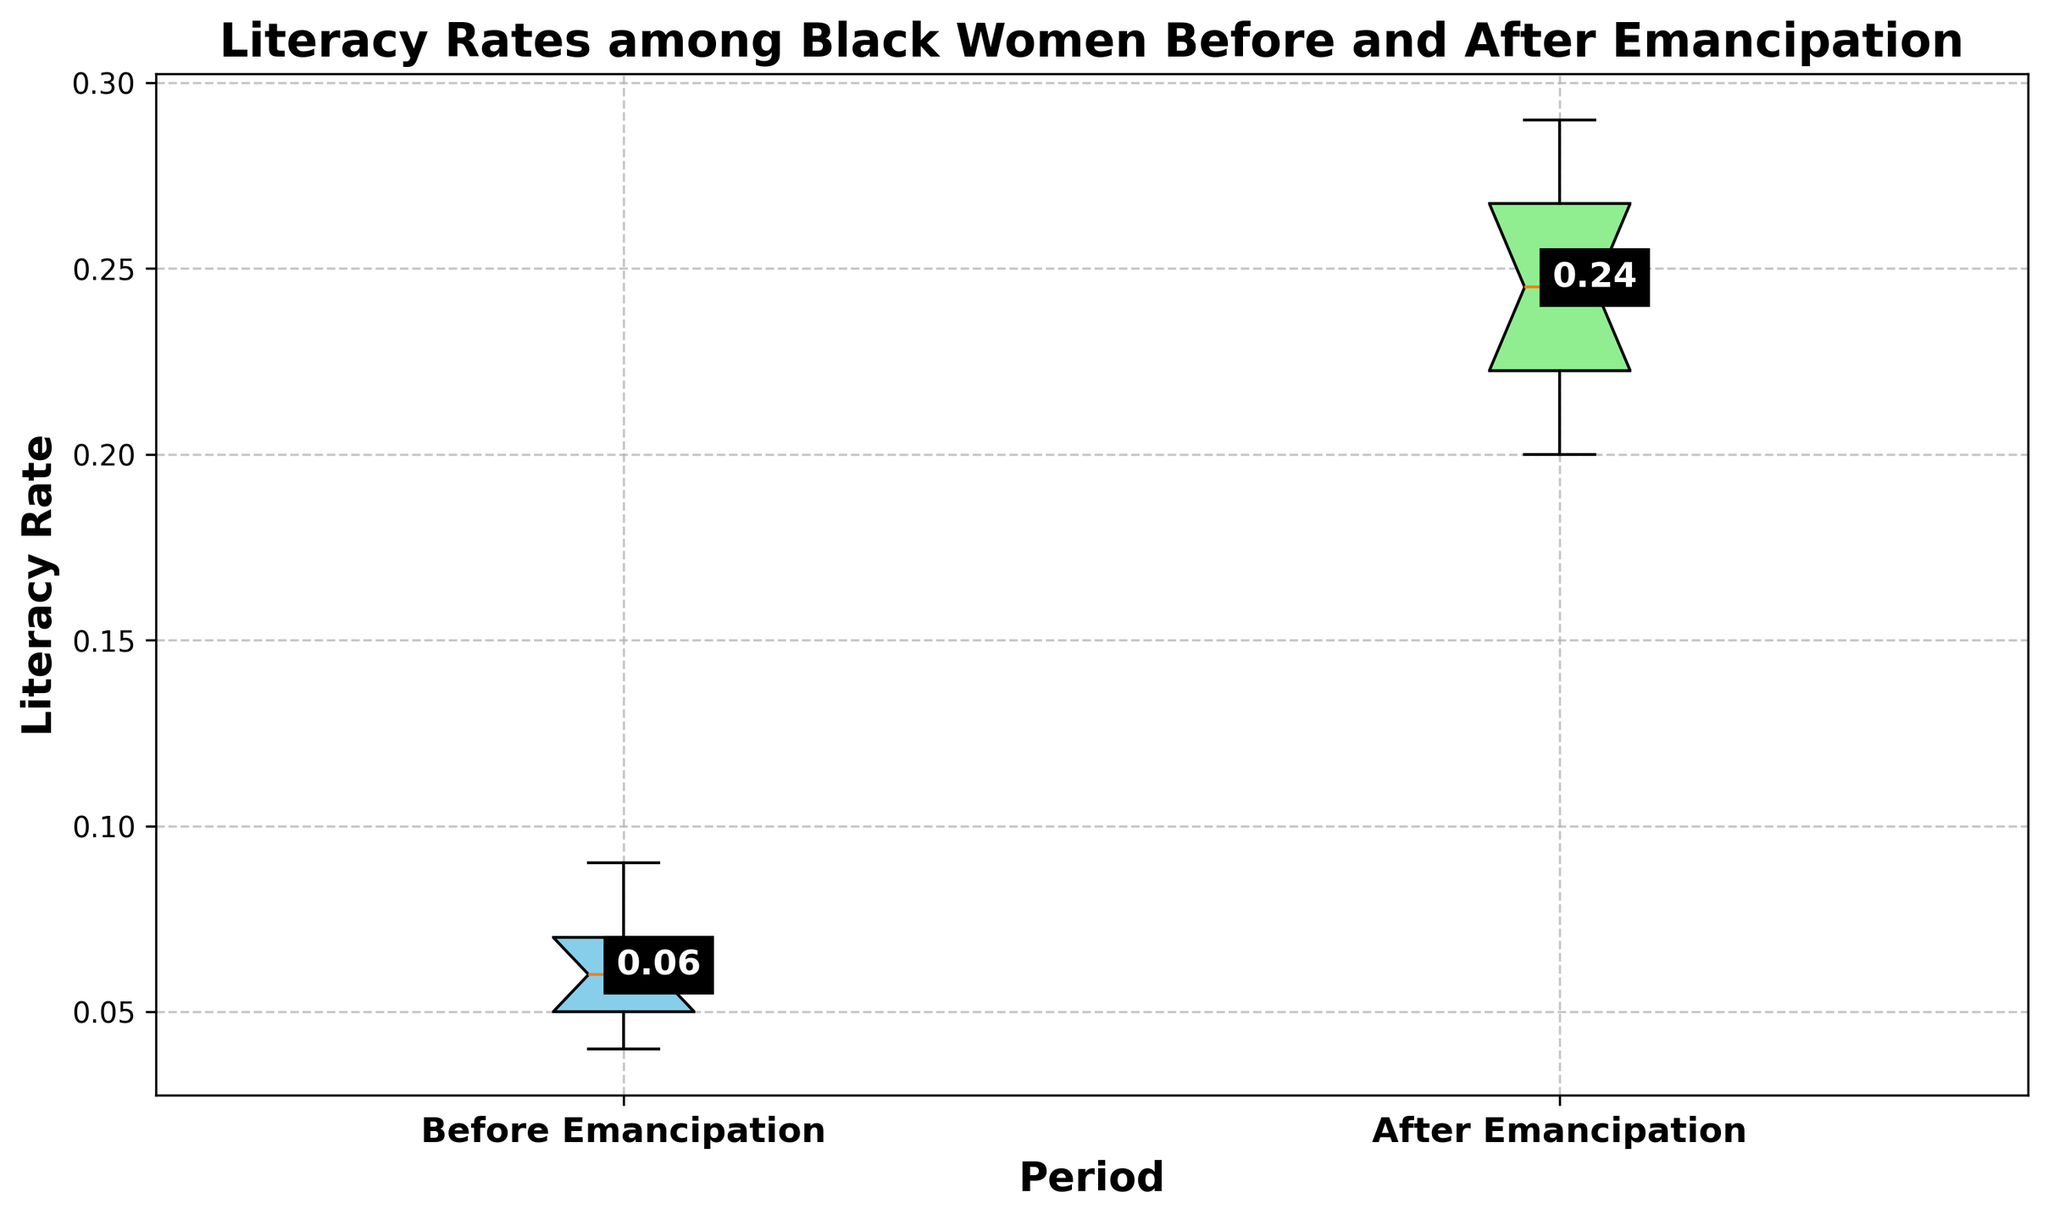What's the median literacy rate before the Emancipation Proclamation? To find the median literacy rate before Emancipation, look at the middle value of the ordered literacy rates in that period, identified by the horizontal line inside the box for "Before Emancipation".
Answer: 0.06 What's the median literacy rate after the Emancipation Proclamation? The median literacy rate after Emancipation, shown by the horizontal line in the box for "After Emancipation", represents the middle value of the ordered literacy rates in that period.
Answer: 0.24 Which period shows a higher median literacy rate? Compare the median lines between the two periods to determine which one is higher. The box for "After Emancipation" has a higher median line than "Before Emancipation".
Answer: After Emancipation What's the difference between the highest literacy rates before and after the Emancipation Proclamation? Identify the top whiskers of the box plots which indicate the maximum literacy rates. For "Before Emancipation" it's 0.09, and for "After Emancipation" it's 0.29. Subtract the former from the latter.
Answer: 0.20 How do the interquartile ranges (IQR) compare between the two periods? The IQR is the range between the first quartile (bottom of the box) and third quartile (top of the box). Compare the height of the boxes for each period. The IQR for "Before Emancipation" is very small, while "After Emancipation" has a larger IQR, indicating higher variability.
Answer: The IQR is larger after Emancipation Is there any overlap in the literacy rates between the two periods? The range of values is indicated by the whiskers of the box plots. The maximum value before Emancipation (0.09) is less than the minimum value after Emancipation (0.20), showing no overlap.
Answer: No What visual attribute indicates the higher literacy rates in the "After Emancipation" group? The box plot for "After Emancipation" is higher on the y-axis, with the median and quartiles all shifted upwards compared to "Before Emancipation".
Answer: Higher placement on the y-axis How does the range of literacy rates compare between the two periods? Examine the whiskers of each box plot. The range for "Before Emancipation" is from 0.04 to 0.09, while for "After Emancipation" it is from 0.20 to 0.29.
Answer: The range is larger after Emancipation 